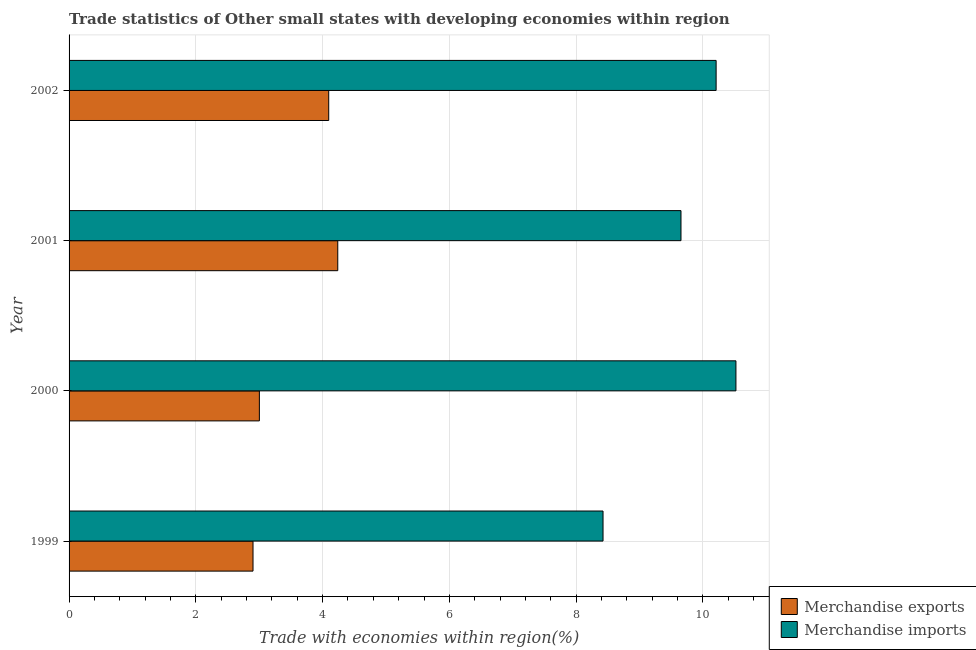How many groups of bars are there?
Your answer should be compact. 4. Are the number of bars on each tick of the Y-axis equal?
Make the answer very short. Yes. How many bars are there on the 3rd tick from the top?
Give a very brief answer. 2. How many bars are there on the 1st tick from the bottom?
Keep it short and to the point. 2. In how many cases, is the number of bars for a given year not equal to the number of legend labels?
Ensure brevity in your answer.  0. What is the merchandise imports in 2001?
Provide a succinct answer. 9.65. Across all years, what is the maximum merchandise exports?
Offer a terse response. 4.24. Across all years, what is the minimum merchandise imports?
Offer a terse response. 8.42. What is the total merchandise exports in the graph?
Give a very brief answer. 14.24. What is the difference between the merchandise imports in 2000 and that in 2002?
Keep it short and to the point. 0.31. What is the difference between the merchandise imports in 1999 and the merchandise exports in 2000?
Provide a succinct answer. 5.42. What is the average merchandise exports per year?
Your response must be concise. 3.56. In the year 2000, what is the difference between the merchandise exports and merchandise imports?
Your answer should be very brief. -7.52. In how many years, is the merchandise imports greater than 3.2 %?
Ensure brevity in your answer.  4. What is the ratio of the merchandise imports in 1999 to that in 2002?
Make the answer very short. 0.82. What is the difference between the highest and the second highest merchandise exports?
Provide a succinct answer. 0.14. What is the difference between the highest and the lowest merchandise exports?
Offer a very short reply. 1.34. In how many years, is the merchandise imports greater than the average merchandise imports taken over all years?
Make the answer very short. 2. Is the sum of the merchandise exports in 1999 and 2001 greater than the maximum merchandise imports across all years?
Give a very brief answer. No. What does the 2nd bar from the bottom in 2000 represents?
Provide a short and direct response. Merchandise imports. Are all the bars in the graph horizontal?
Ensure brevity in your answer.  Yes. How many years are there in the graph?
Your answer should be very brief. 4. What is the difference between two consecutive major ticks on the X-axis?
Provide a succinct answer. 2. Does the graph contain grids?
Offer a terse response. Yes. Where does the legend appear in the graph?
Ensure brevity in your answer.  Bottom right. How many legend labels are there?
Provide a succinct answer. 2. How are the legend labels stacked?
Offer a terse response. Vertical. What is the title of the graph?
Provide a short and direct response. Trade statistics of Other small states with developing economies within region. What is the label or title of the X-axis?
Make the answer very short. Trade with economies within region(%). What is the Trade with economies within region(%) of Merchandise exports in 1999?
Give a very brief answer. 2.9. What is the Trade with economies within region(%) in Merchandise imports in 1999?
Your answer should be compact. 8.42. What is the Trade with economies within region(%) in Merchandise exports in 2000?
Provide a short and direct response. 3. What is the Trade with economies within region(%) in Merchandise imports in 2000?
Give a very brief answer. 10.52. What is the Trade with economies within region(%) of Merchandise exports in 2001?
Your answer should be very brief. 4.24. What is the Trade with economies within region(%) in Merchandise imports in 2001?
Your response must be concise. 9.65. What is the Trade with economies within region(%) of Merchandise exports in 2002?
Your answer should be very brief. 4.1. What is the Trade with economies within region(%) of Merchandise imports in 2002?
Your response must be concise. 10.21. Across all years, what is the maximum Trade with economies within region(%) in Merchandise exports?
Your answer should be very brief. 4.24. Across all years, what is the maximum Trade with economies within region(%) of Merchandise imports?
Make the answer very short. 10.52. Across all years, what is the minimum Trade with economies within region(%) of Merchandise exports?
Your answer should be very brief. 2.9. Across all years, what is the minimum Trade with economies within region(%) in Merchandise imports?
Make the answer very short. 8.42. What is the total Trade with economies within region(%) in Merchandise exports in the graph?
Your answer should be compact. 14.24. What is the total Trade with economies within region(%) in Merchandise imports in the graph?
Your response must be concise. 38.8. What is the difference between the Trade with economies within region(%) of Merchandise exports in 1999 and that in 2000?
Your response must be concise. -0.1. What is the difference between the Trade with economies within region(%) of Merchandise imports in 1999 and that in 2000?
Ensure brevity in your answer.  -2.1. What is the difference between the Trade with economies within region(%) in Merchandise exports in 1999 and that in 2001?
Provide a short and direct response. -1.34. What is the difference between the Trade with economies within region(%) of Merchandise imports in 1999 and that in 2001?
Ensure brevity in your answer.  -1.23. What is the difference between the Trade with economies within region(%) of Merchandise exports in 1999 and that in 2002?
Provide a short and direct response. -1.19. What is the difference between the Trade with economies within region(%) in Merchandise imports in 1999 and that in 2002?
Provide a short and direct response. -1.78. What is the difference between the Trade with economies within region(%) in Merchandise exports in 2000 and that in 2001?
Your answer should be compact. -1.24. What is the difference between the Trade with economies within region(%) in Merchandise imports in 2000 and that in 2001?
Offer a very short reply. 0.87. What is the difference between the Trade with economies within region(%) of Merchandise exports in 2000 and that in 2002?
Your answer should be very brief. -1.09. What is the difference between the Trade with economies within region(%) in Merchandise imports in 2000 and that in 2002?
Your response must be concise. 0.31. What is the difference between the Trade with economies within region(%) in Merchandise exports in 2001 and that in 2002?
Make the answer very short. 0.14. What is the difference between the Trade with economies within region(%) of Merchandise imports in 2001 and that in 2002?
Provide a short and direct response. -0.55. What is the difference between the Trade with economies within region(%) of Merchandise exports in 1999 and the Trade with economies within region(%) of Merchandise imports in 2000?
Offer a very short reply. -7.62. What is the difference between the Trade with economies within region(%) of Merchandise exports in 1999 and the Trade with economies within region(%) of Merchandise imports in 2001?
Provide a succinct answer. -6.75. What is the difference between the Trade with economies within region(%) of Merchandise exports in 1999 and the Trade with economies within region(%) of Merchandise imports in 2002?
Make the answer very short. -7.31. What is the difference between the Trade with economies within region(%) in Merchandise exports in 2000 and the Trade with economies within region(%) in Merchandise imports in 2001?
Give a very brief answer. -6.65. What is the difference between the Trade with economies within region(%) in Merchandise exports in 2000 and the Trade with economies within region(%) in Merchandise imports in 2002?
Provide a short and direct response. -7.21. What is the difference between the Trade with economies within region(%) in Merchandise exports in 2001 and the Trade with economies within region(%) in Merchandise imports in 2002?
Offer a very short reply. -5.97. What is the average Trade with economies within region(%) of Merchandise exports per year?
Your answer should be compact. 3.56. What is the average Trade with economies within region(%) in Merchandise imports per year?
Offer a very short reply. 9.7. In the year 1999, what is the difference between the Trade with economies within region(%) in Merchandise exports and Trade with economies within region(%) in Merchandise imports?
Your answer should be very brief. -5.52. In the year 2000, what is the difference between the Trade with economies within region(%) in Merchandise exports and Trade with economies within region(%) in Merchandise imports?
Your answer should be very brief. -7.52. In the year 2001, what is the difference between the Trade with economies within region(%) in Merchandise exports and Trade with economies within region(%) in Merchandise imports?
Offer a terse response. -5.41. In the year 2002, what is the difference between the Trade with economies within region(%) in Merchandise exports and Trade with economies within region(%) in Merchandise imports?
Offer a very short reply. -6.11. What is the ratio of the Trade with economies within region(%) of Merchandise exports in 1999 to that in 2000?
Provide a succinct answer. 0.97. What is the ratio of the Trade with economies within region(%) of Merchandise imports in 1999 to that in 2000?
Your response must be concise. 0.8. What is the ratio of the Trade with economies within region(%) of Merchandise exports in 1999 to that in 2001?
Your answer should be compact. 0.68. What is the ratio of the Trade with economies within region(%) of Merchandise imports in 1999 to that in 2001?
Ensure brevity in your answer.  0.87. What is the ratio of the Trade with economies within region(%) in Merchandise exports in 1999 to that in 2002?
Offer a very short reply. 0.71. What is the ratio of the Trade with economies within region(%) in Merchandise imports in 1999 to that in 2002?
Provide a short and direct response. 0.83. What is the ratio of the Trade with economies within region(%) of Merchandise exports in 2000 to that in 2001?
Offer a very short reply. 0.71. What is the ratio of the Trade with economies within region(%) of Merchandise imports in 2000 to that in 2001?
Keep it short and to the point. 1.09. What is the ratio of the Trade with economies within region(%) of Merchandise exports in 2000 to that in 2002?
Keep it short and to the point. 0.73. What is the ratio of the Trade with economies within region(%) in Merchandise imports in 2000 to that in 2002?
Make the answer very short. 1.03. What is the ratio of the Trade with economies within region(%) in Merchandise exports in 2001 to that in 2002?
Give a very brief answer. 1.03. What is the ratio of the Trade with economies within region(%) in Merchandise imports in 2001 to that in 2002?
Keep it short and to the point. 0.95. What is the difference between the highest and the second highest Trade with economies within region(%) of Merchandise exports?
Keep it short and to the point. 0.14. What is the difference between the highest and the second highest Trade with economies within region(%) in Merchandise imports?
Keep it short and to the point. 0.31. What is the difference between the highest and the lowest Trade with economies within region(%) in Merchandise exports?
Your answer should be very brief. 1.34. What is the difference between the highest and the lowest Trade with economies within region(%) in Merchandise imports?
Make the answer very short. 2.1. 